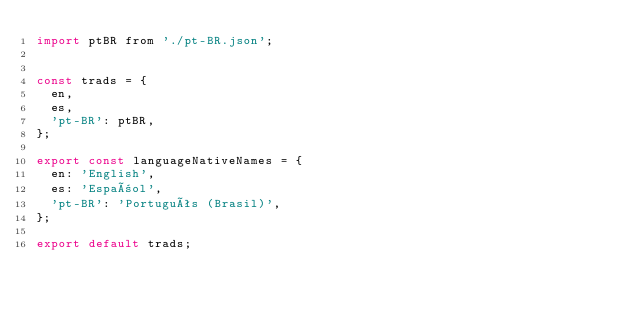Convert code to text. <code><loc_0><loc_0><loc_500><loc_500><_JavaScript_>import ptBR from './pt-BR.json';


const trads = {
  en,
  es,
  'pt-BR': ptBR,
};

export const languageNativeNames = {
  en: 'English',
  es: 'Español',
  'pt-BR': 'Português (Brasil)',
};

export default trads;
</code> 